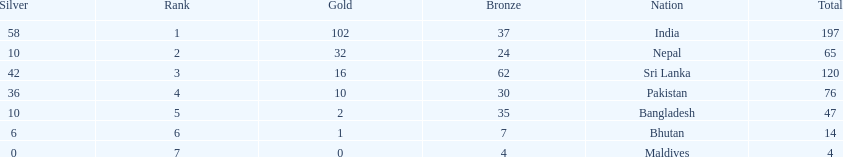Name a country listed in the table, other than india? Nepal. 